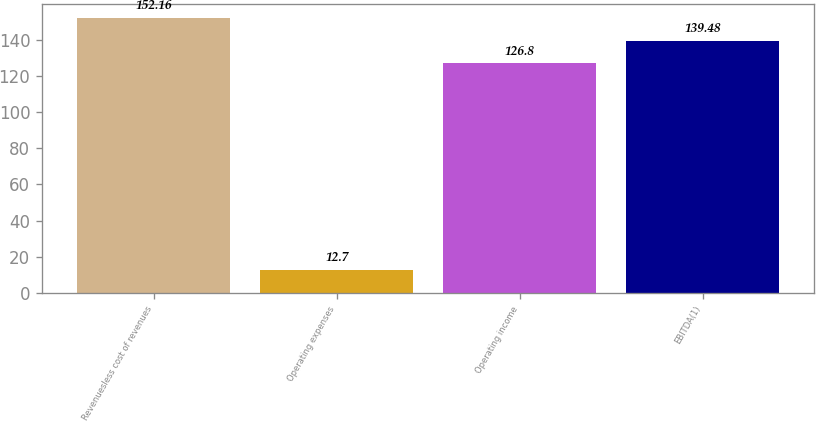Convert chart. <chart><loc_0><loc_0><loc_500><loc_500><bar_chart><fcel>Revenuesless cost of revenues<fcel>Operating expenses<fcel>Operating income<fcel>EBITDA(1)<nl><fcel>152.16<fcel>12.7<fcel>126.8<fcel>139.48<nl></chart> 